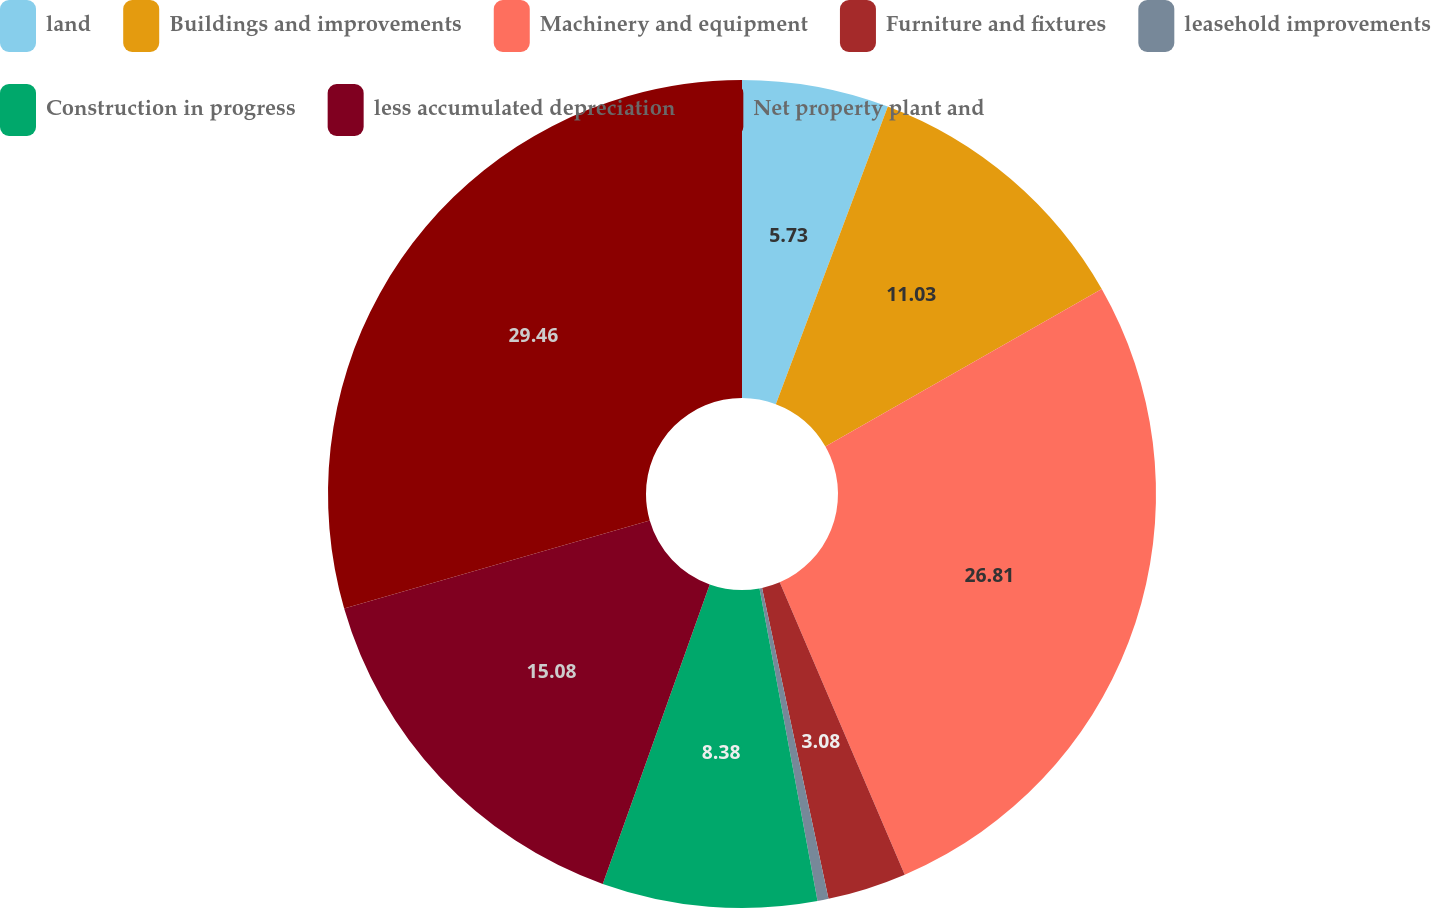Convert chart to OTSL. <chart><loc_0><loc_0><loc_500><loc_500><pie_chart><fcel>land<fcel>Buildings and improvements<fcel>Machinery and equipment<fcel>Furniture and fixtures<fcel>leasehold improvements<fcel>Construction in progress<fcel>less accumulated depreciation<fcel>Net property plant and<nl><fcel>5.73%<fcel>11.03%<fcel>26.81%<fcel>3.08%<fcel>0.43%<fcel>8.38%<fcel>15.08%<fcel>29.46%<nl></chart> 